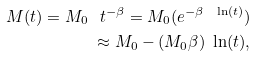<formula> <loc_0><loc_0><loc_500><loc_500>M ( t ) = M _ { 0 } \ t ^ { - \beta } = M _ { 0 } ( e ^ { - \beta \ \ln ( t ) } ) \\ \approx M _ { 0 } - ( M _ { 0 } \beta ) \ \ln ( t ) ,</formula> 